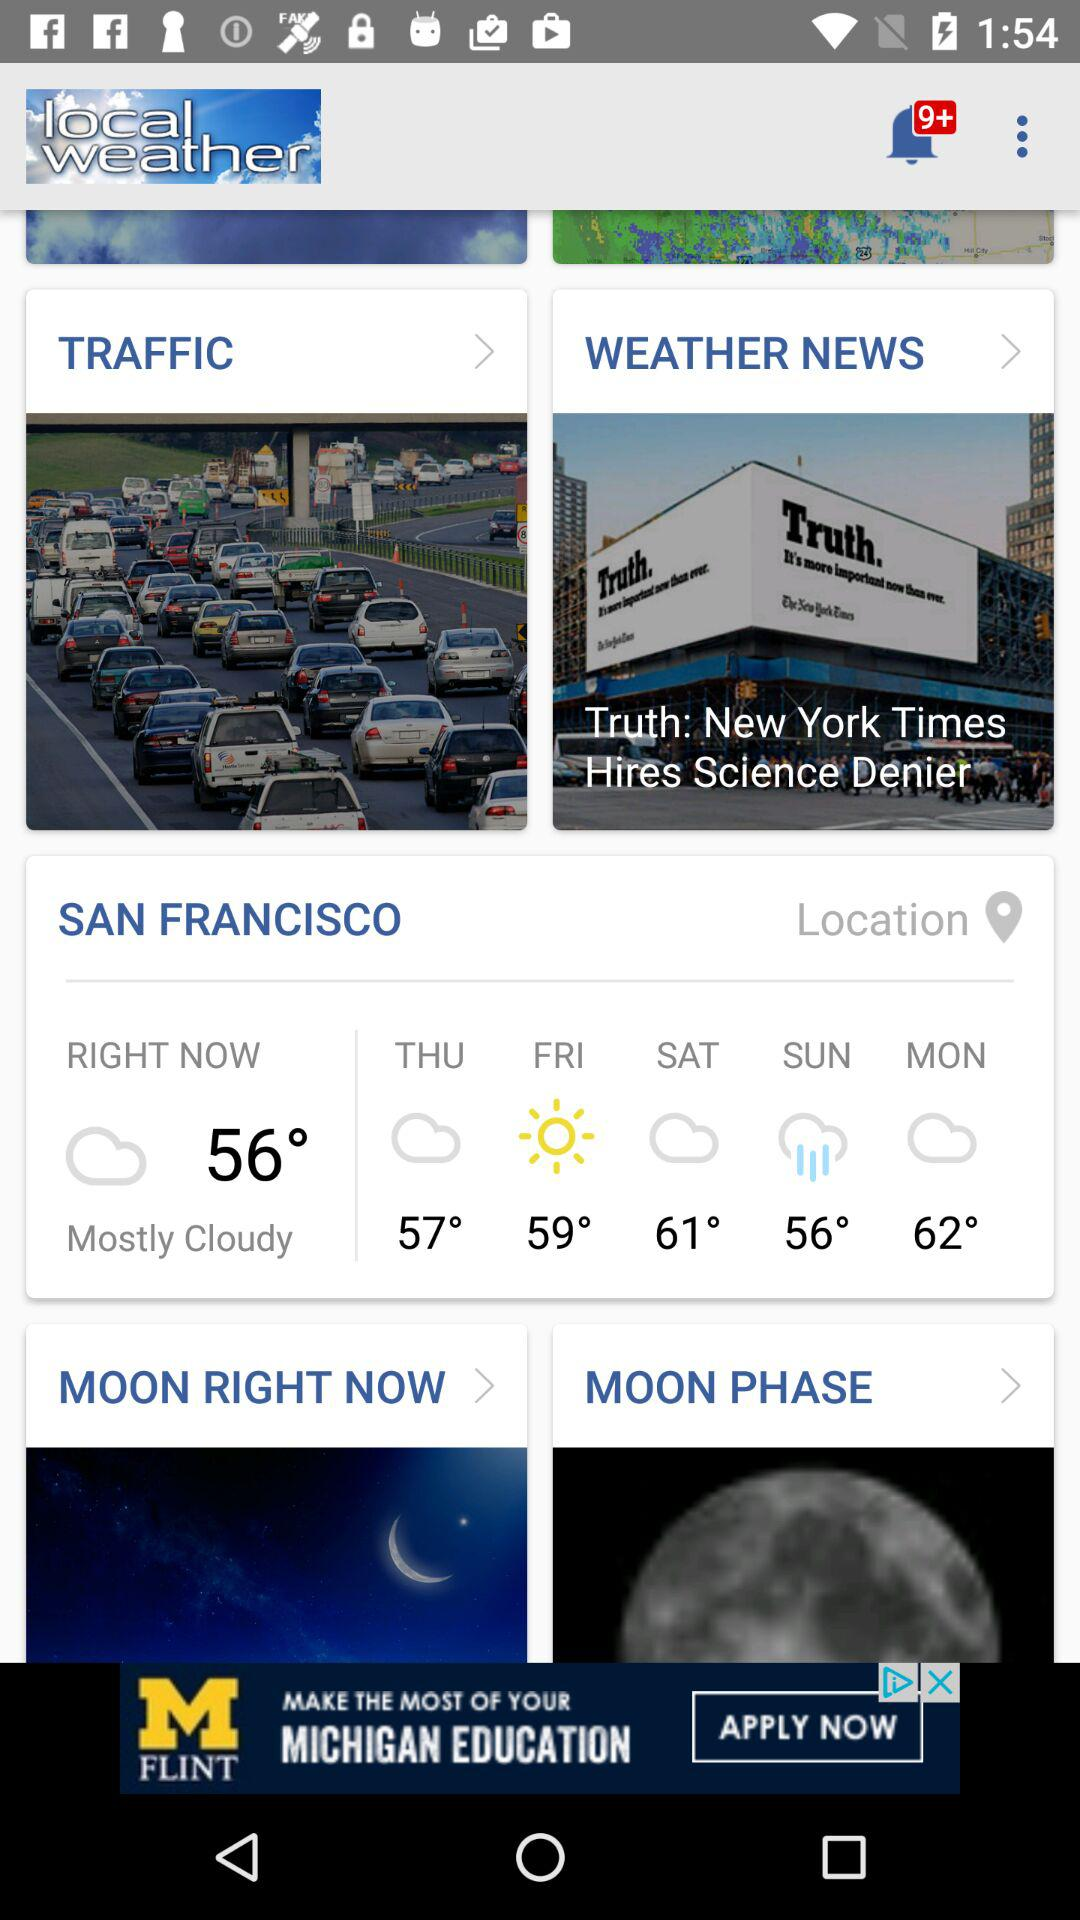What is the temperature high for Tuesday?
When the provided information is insufficient, respond with <no answer>. <no answer> 